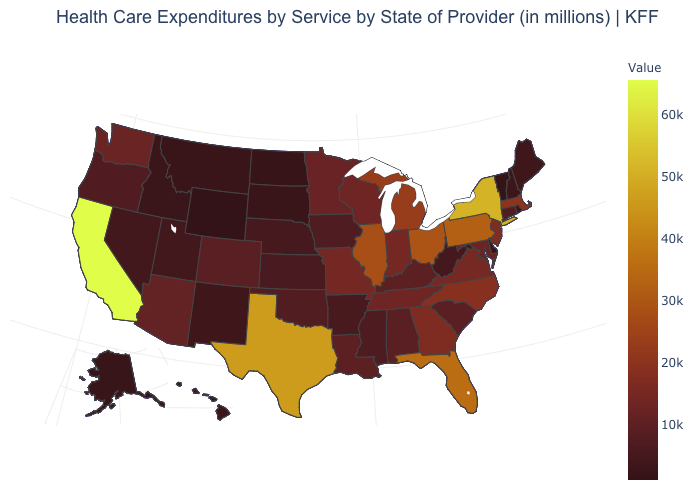Among the states that border Oklahoma , which have the lowest value?
Answer briefly. New Mexico. Does New York have the highest value in the Northeast?
Answer briefly. Yes. Which states have the lowest value in the USA?
Be succinct. Wyoming. Which states have the lowest value in the MidWest?
Short answer required. North Dakota. Which states have the lowest value in the MidWest?
Be succinct. North Dakota. Does New York have the highest value in the Northeast?
Be succinct. Yes. Does New York have the highest value in the Northeast?
Quick response, please. Yes. 